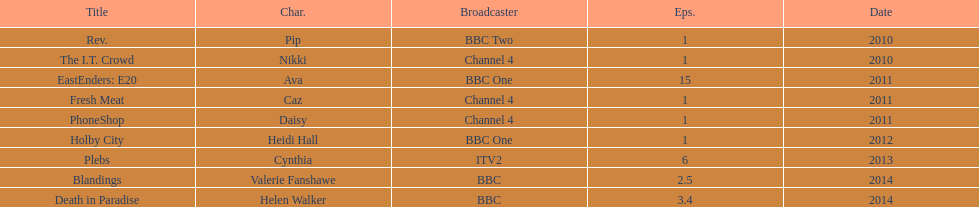What was the previous role this actress played before playing cynthia in plebs? Heidi Hall. 